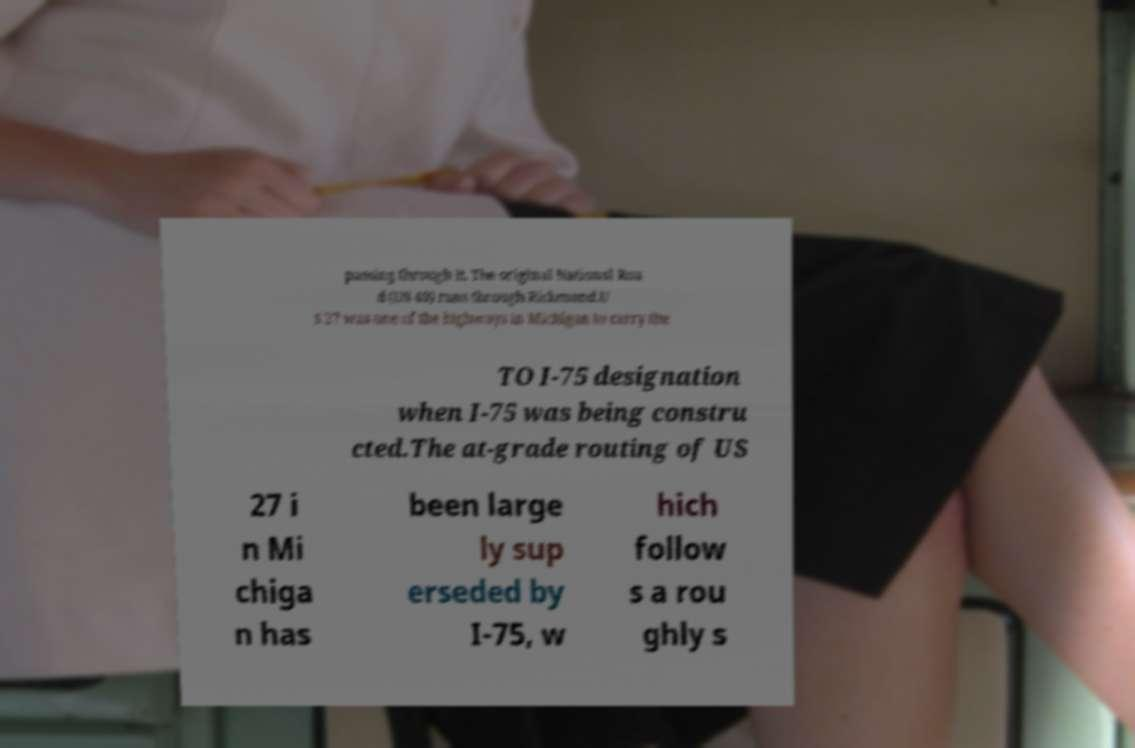Please read and relay the text visible in this image. What does it say? passing through it. The original National Roa d (US 40) runs through Richmond.U S 27 was one of the highways in Michigan to carry the TO I-75 designation when I-75 was being constru cted.The at-grade routing of US 27 i n Mi chiga n has been large ly sup erseded by I-75, w hich follow s a rou ghly s 